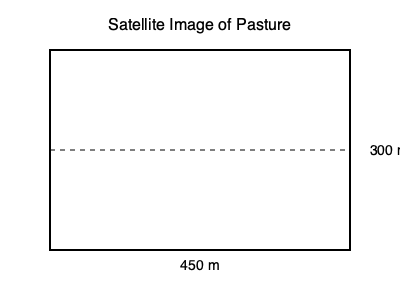You've received a satellite image of your rectangular pasture. The image shows that the pasture measures 450 meters in length and 300 meters in width. What is the total area of the pasture in hectares? To solve this problem, we'll follow these steps:

1. Calculate the area of the pasture in square meters:
   - Area = Length × Width
   - Area = 450 m × 300 m = 135,000 m²

2. Convert square meters to hectares:
   - 1 hectare = 10,000 m²
   - To convert, divide the area in m² by 10,000
   - Hectares = 135,000 m² ÷ 10,000 m²/ha
   - Hectares = 13.5 ha

Therefore, the total area of the pasture is 13.5 hectares.
Answer: 13.5 ha 